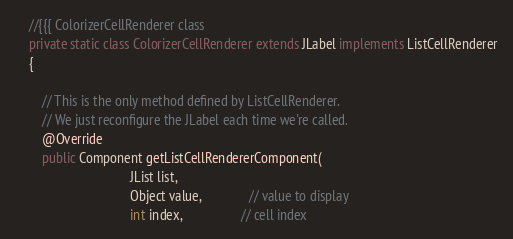Convert code to text. <code><loc_0><loc_0><loc_500><loc_500><_Java_>
	//{{{ ColorizerCellRenderer class
	private static class ColorizerCellRenderer extends JLabel implements ListCellRenderer
	{

		// This is the only method defined by ListCellRenderer.
		// We just reconfigure the JLabel each time we're called.
		@Override
		public Component getListCellRendererComponent(
							      JList list,
							      Object value,              // value to display
							      int index,                 // cell index</code> 